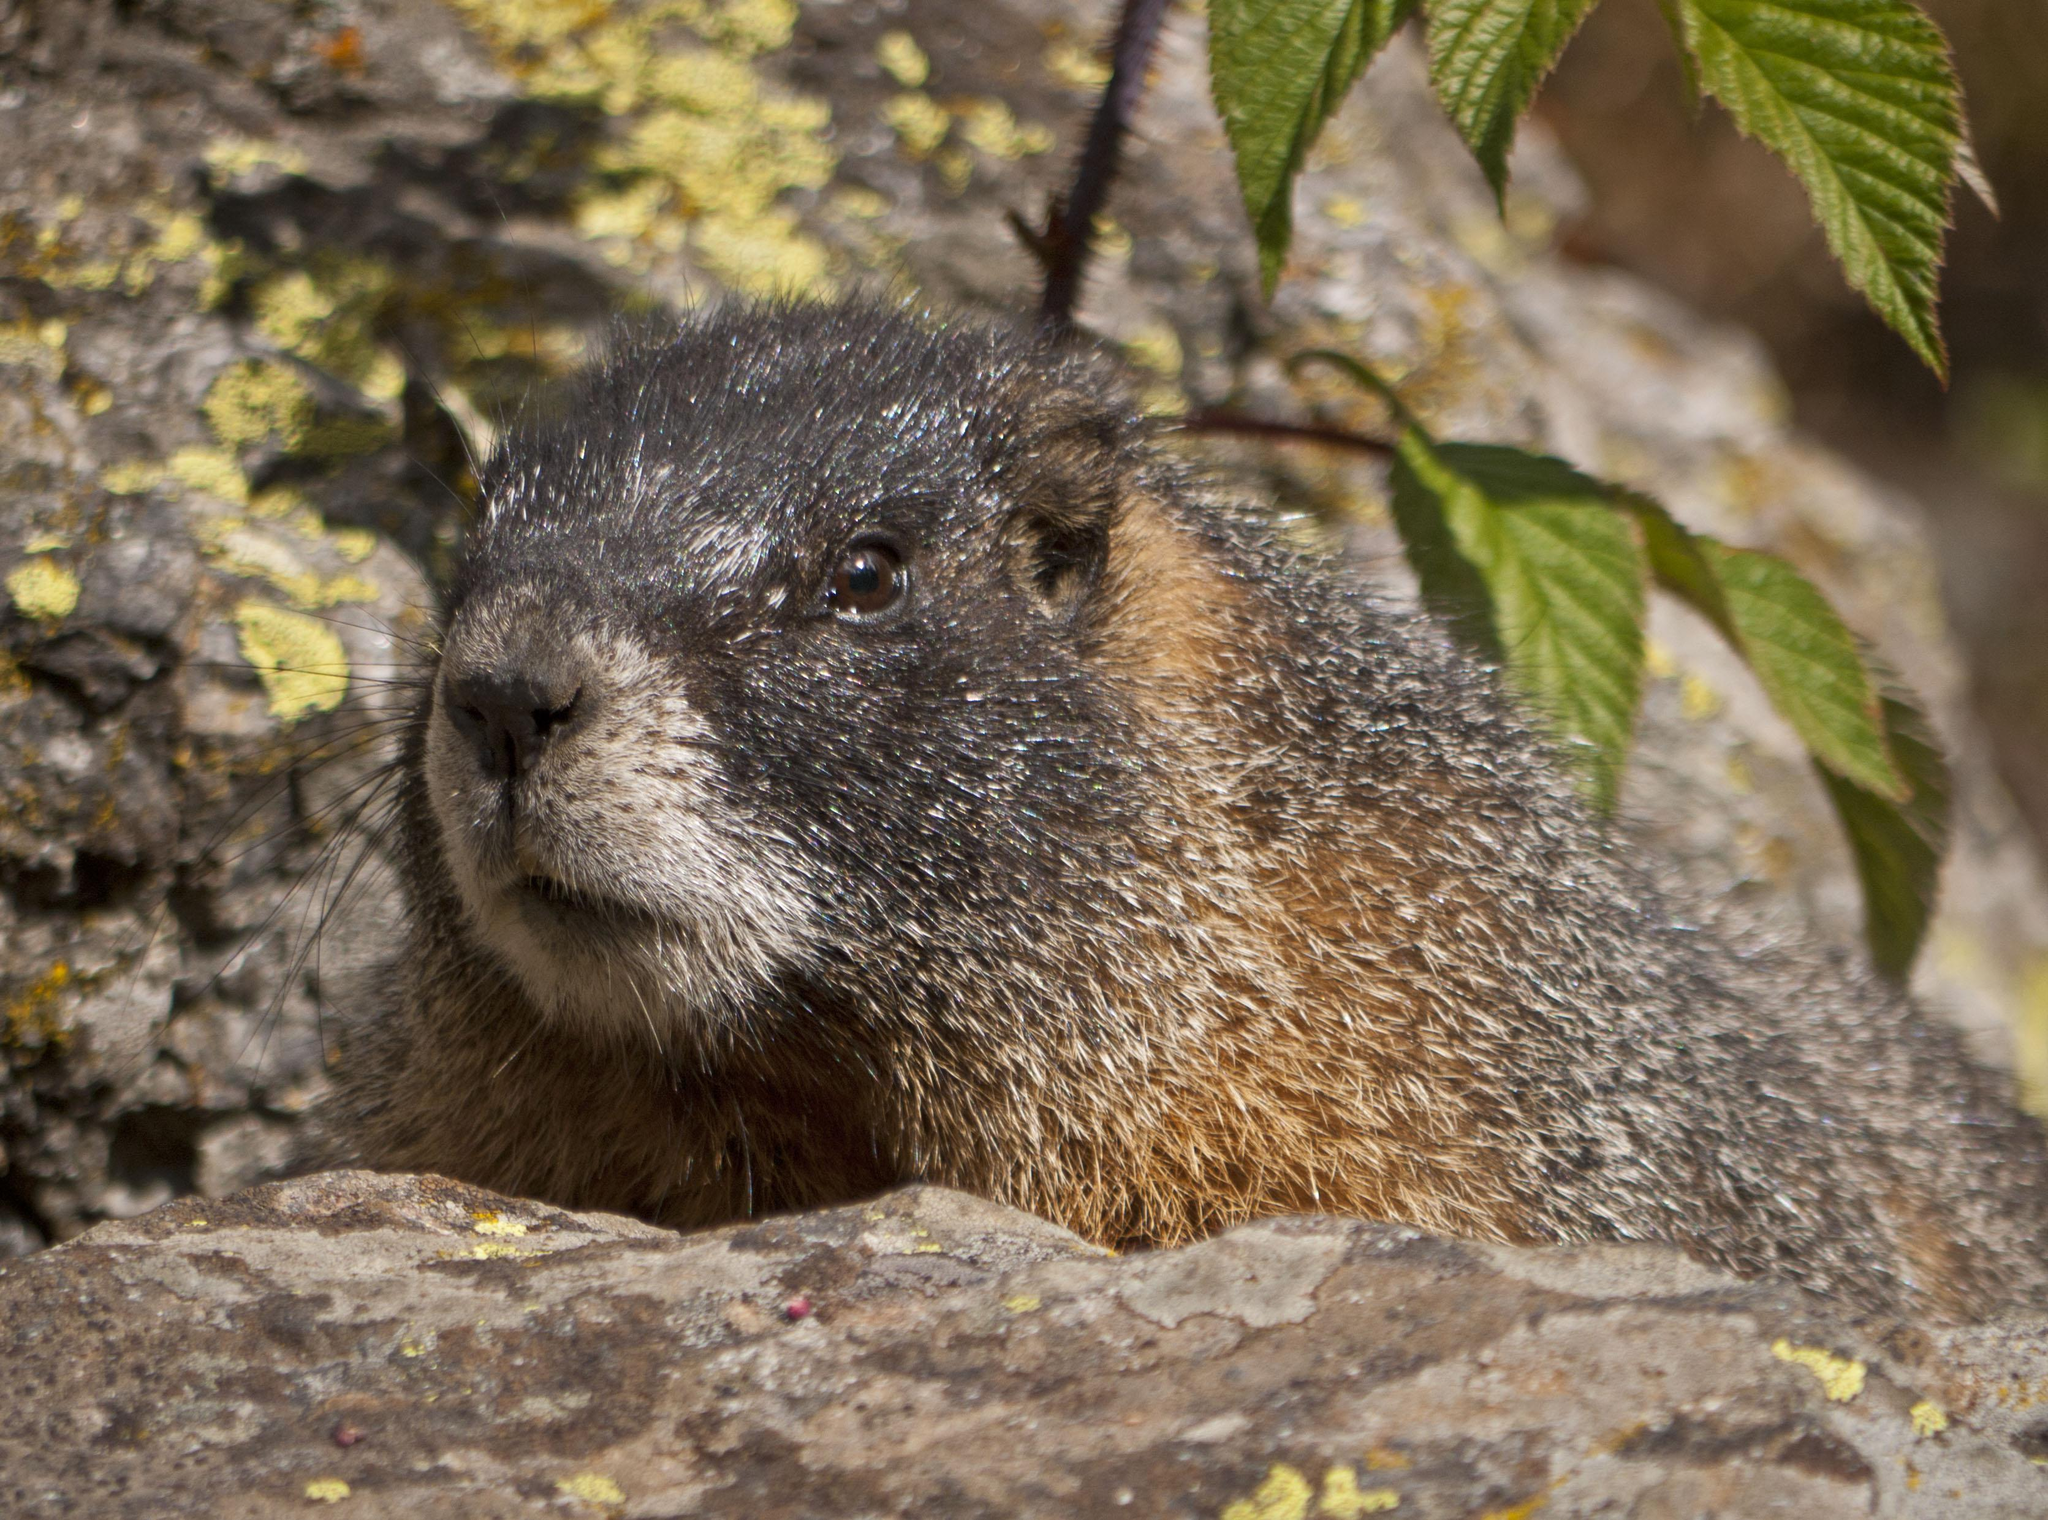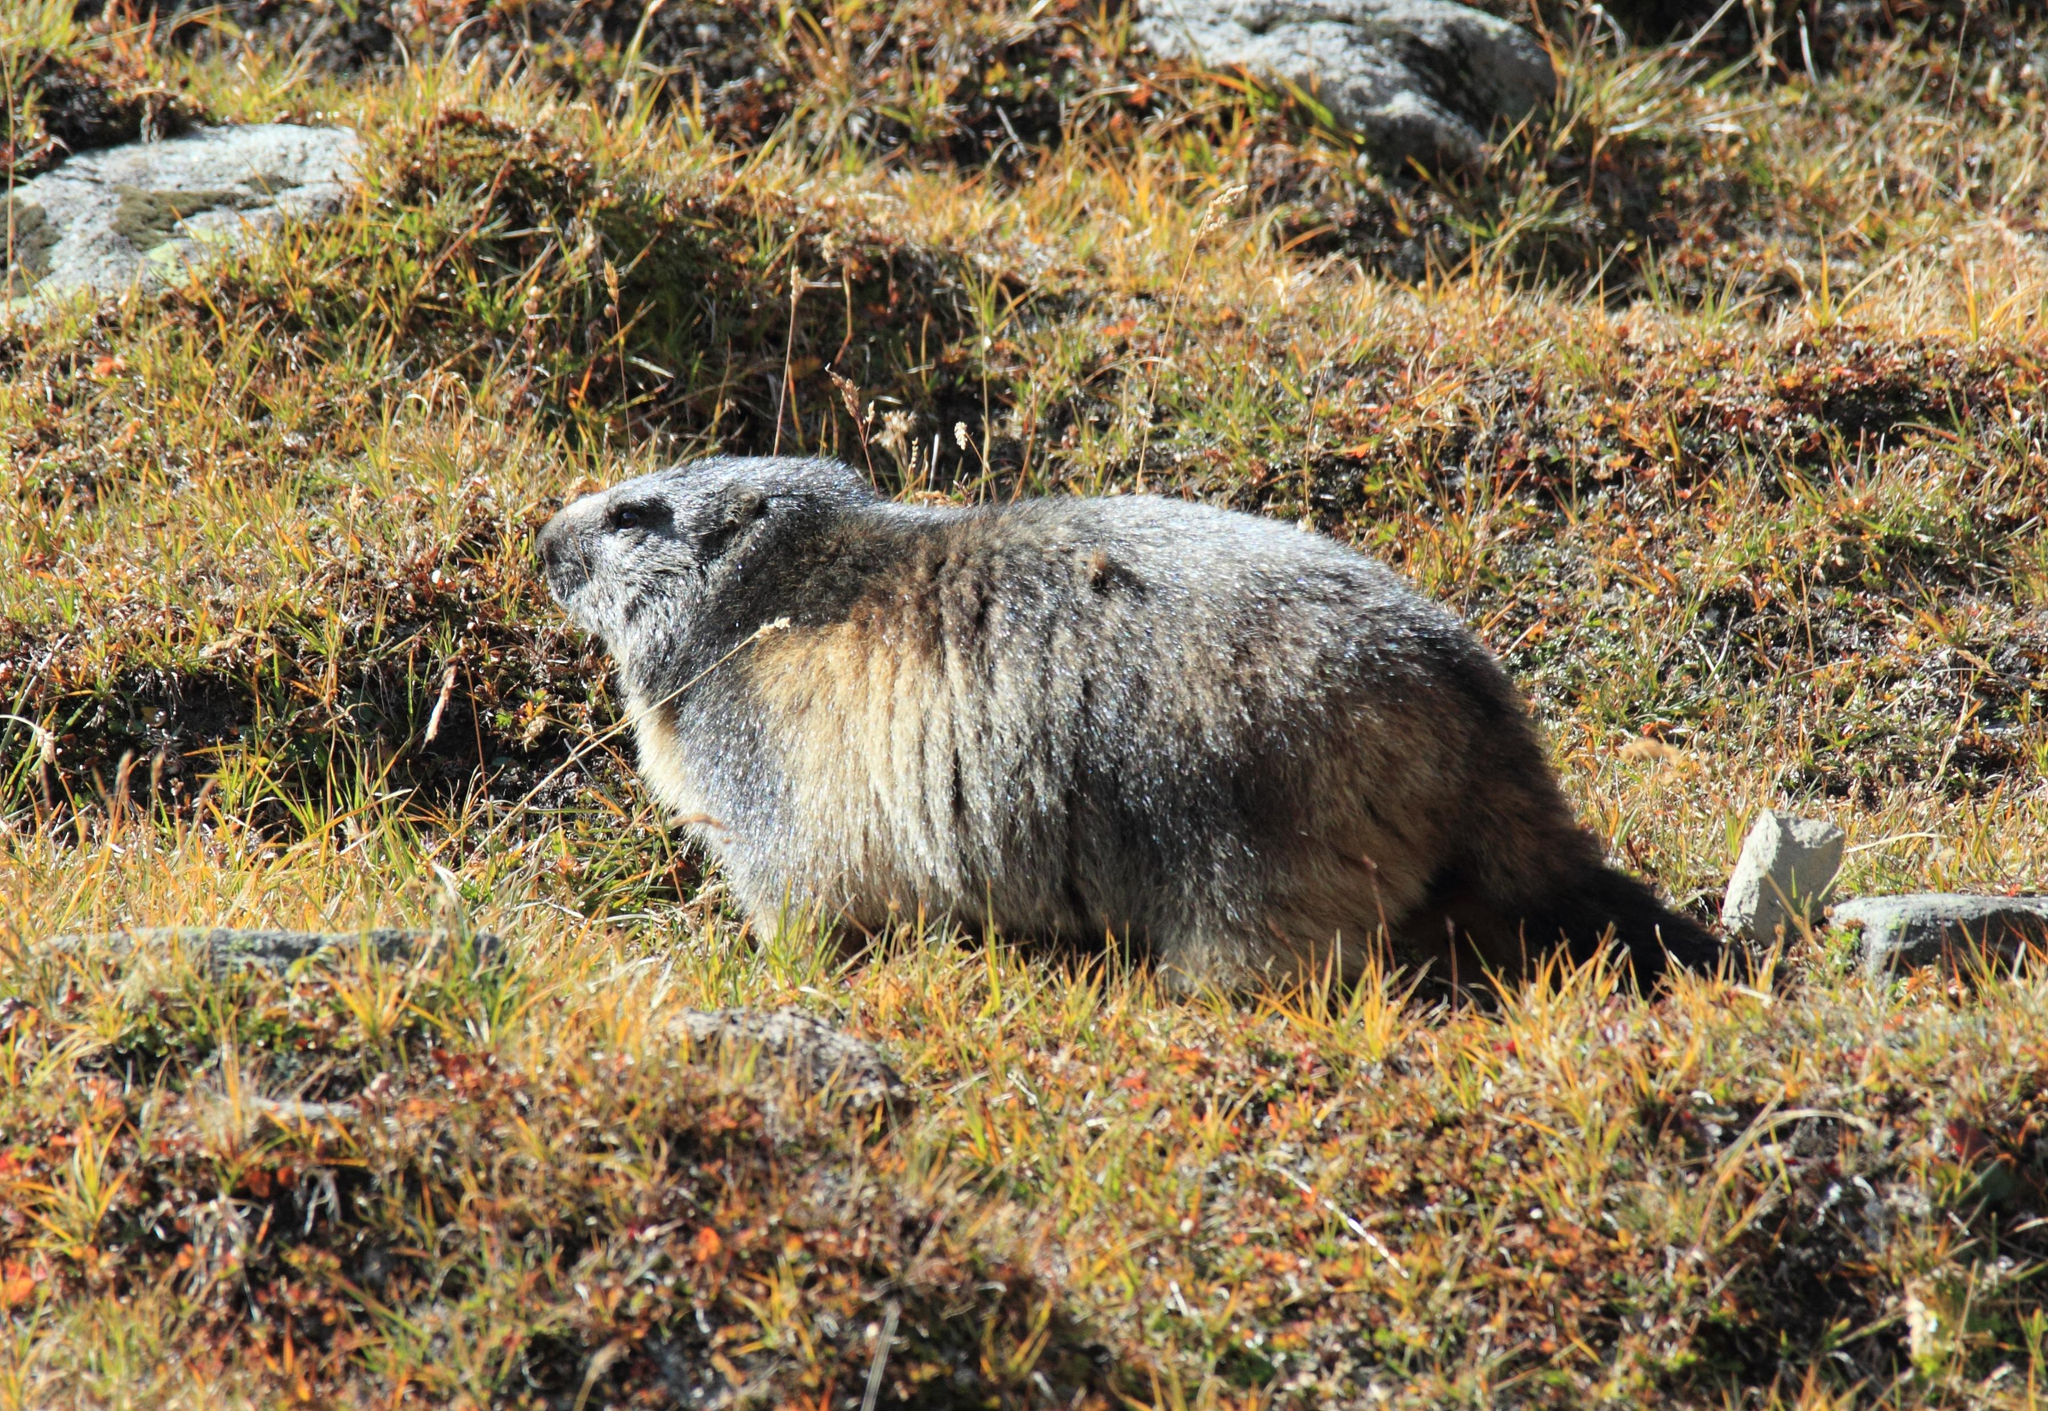The first image is the image on the left, the second image is the image on the right. Analyze the images presented: Is the assertion "The animal in the image on the right is looking toward the camera" valid? Answer yes or no. No. 